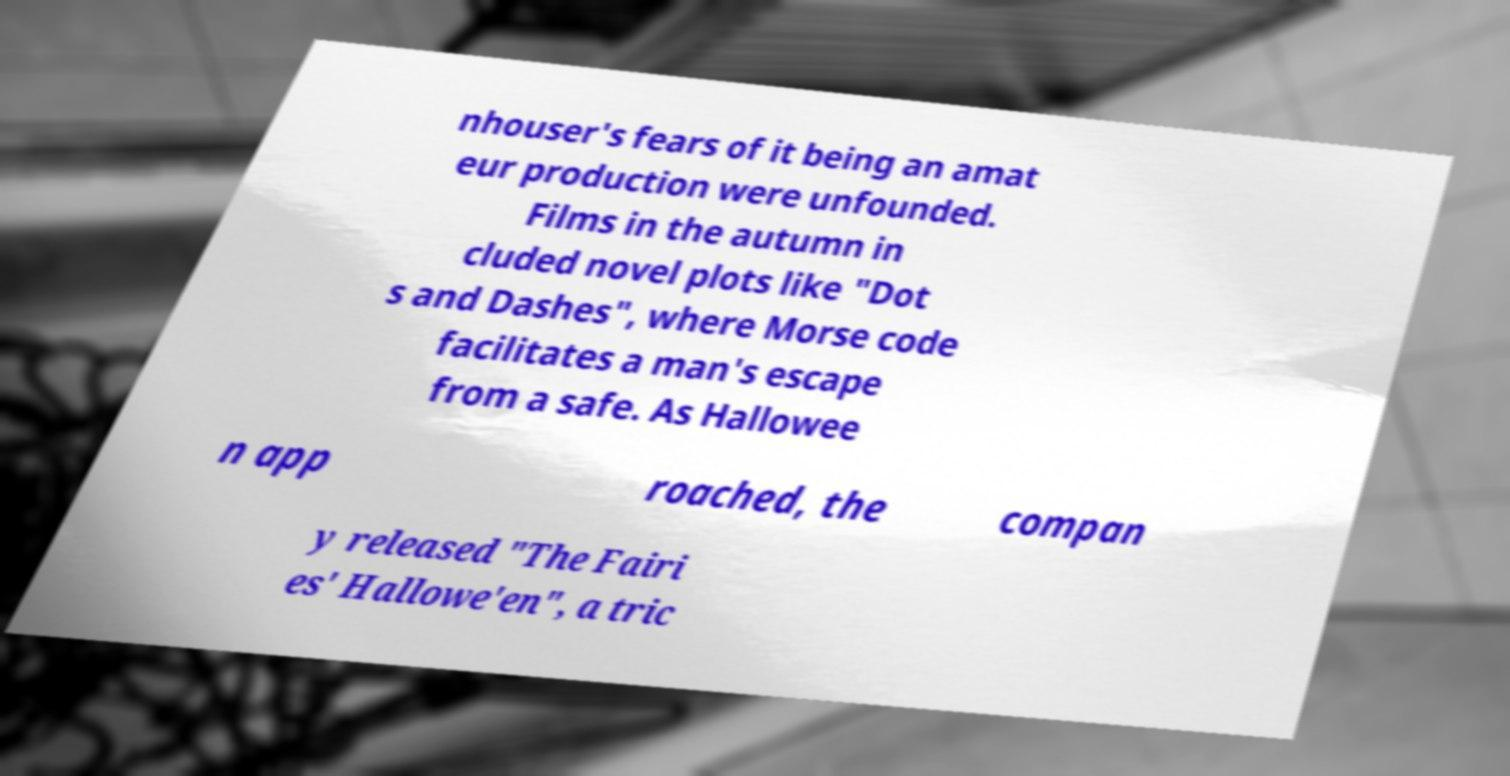There's text embedded in this image that I need extracted. Can you transcribe it verbatim? nhouser's fears of it being an amat eur production were unfounded. Films in the autumn in cluded novel plots like "Dot s and Dashes", where Morse code facilitates a man's escape from a safe. As Hallowee n app roached, the compan y released "The Fairi es' Hallowe'en", a tric 